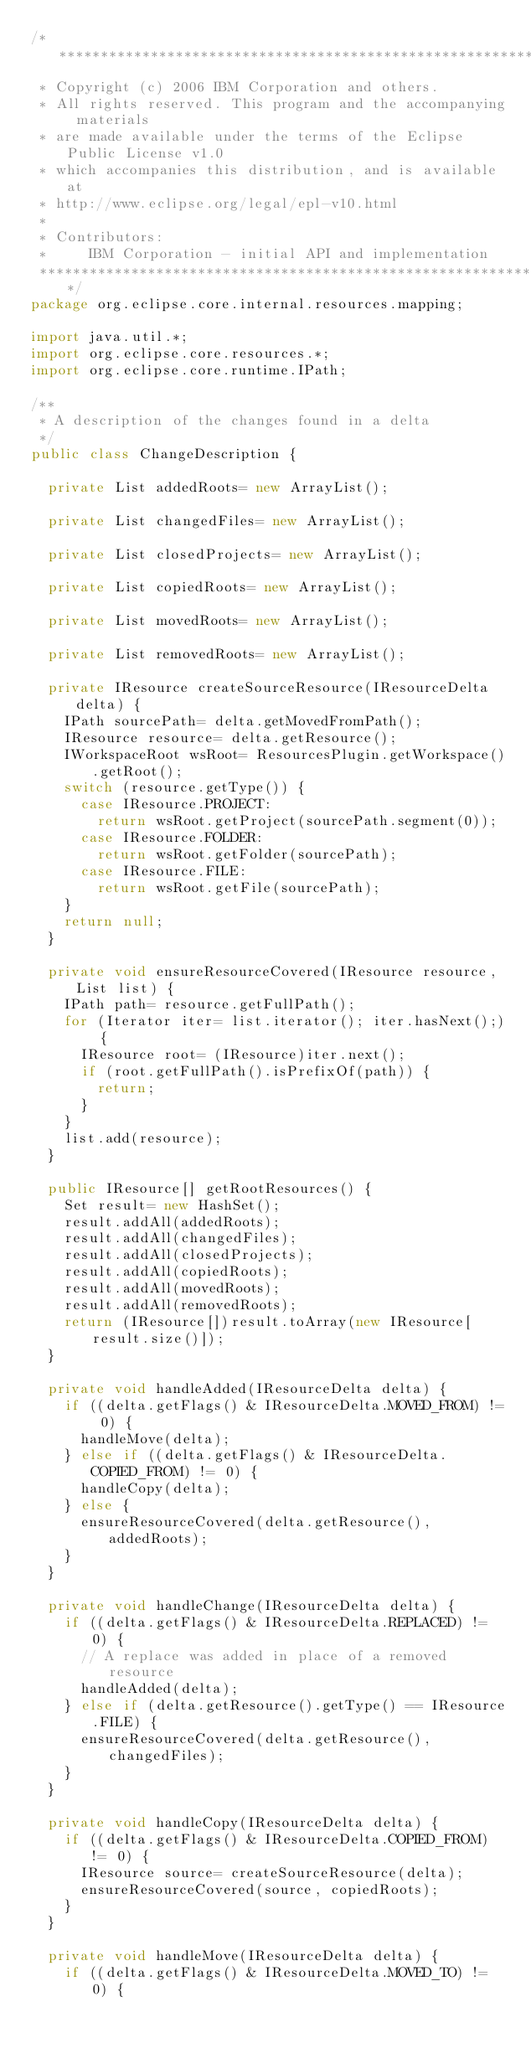<code> <loc_0><loc_0><loc_500><loc_500><_Java_>/*******************************************************************************
 * Copyright (c) 2006 IBM Corporation and others.
 * All rights reserved. This program and the accompanying materials
 * are made available under the terms of the Eclipse Public License v1.0
 * which accompanies this distribution, and is available at
 * http://www.eclipse.org/legal/epl-v10.html
 * 
 * Contributors:
 *     IBM Corporation - initial API and implementation
 *******************************************************************************/
package org.eclipse.core.internal.resources.mapping;

import java.util.*;
import org.eclipse.core.resources.*;
import org.eclipse.core.runtime.IPath;

/**
 * A description of the changes found in a delta
 */
public class ChangeDescription {

	private List addedRoots= new ArrayList();

	private List changedFiles= new ArrayList();

	private List closedProjects= new ArrayList();

	private List copiedRoots= new ArrayList();

	private List movedRoots= new ArrayList();

	private List removedRoots= new ArrayList();

	private IResource createSourceResource(IResourceDelta delta) {
		IPath sourcePath= delta.getMovedFromPath();
		IResource resource= delta.getResource();
		IWorkspaceRoot wsRoot= ResourcesPlugin.getWorkspace().getRoot();
		switch (resource.getType()) {
			case IResource.PROJECT:
				return wsRoot.getProject(sourcePath.segment(0));
			case IResource.FOLDER:
				return wsRoot.getFolder(sourcePath);
			case IResource.FILE:
				return wsRoot.getFile(sourcePath);
		}
		return null;
	}

	private void ensureResourceCovered(IResource resource, List list) {
		IPath path= resource.getFullPath();
		for (Iterator iter= list.iterator(); iter.hasNext();) {
			IResource root= (IResource)iter.next();
			if (root.getFullPath().isPrefixOf(path)) {
				return;
			}
		}
		list.add(resource);
	}

	public IResource[] getRootResources() {
		Set result= new HashSet();
		result.addAll(addedRoots);
		result.addAll(changedFiles);
		result.addAll(closedProjects);
		result.addAll(copiedRoots);
		result.addAll(movedRoots);
		result.addAll(removedRoots);
		return (IResource[])result.toArray(new IResource[result.size()]);
	}

	private void handleAdded(IResourceDelta delta) {
		if ((delta.getFlags() & IResourceDelta.MOVED_FROM) != 0) {
			handleMove(delta);
		} else if ((delta.getFlags() & IResourceDelta.COPIED_FROM) != 0) {
			handleCopy(delta);
		} else {
			ensureResourceCovered(delta.getResource(), addedRoots);
		}
	}

	private void handleChange(IResourceDelta delta) {
		if ((delta.getFlags() & IResourceDelta.REPLACED) != 0) {
			// A replace was added in place of a removed resource
			handleAdded(delta);
		} else if (delta.getResource().getType() == IResource.FILE) {
			ensureResourceCovered(delta.getResource(), changedFiles);
		}
	}

	private void handleCopy(IResourceDelta delta) {
		if ((delta.getFlags() & IResourceDelta.COPIED_FROM) != 0) {
			IResource source= createSourceResource(delta);
			ensureResourceCovered(source, copiedRoots);
		}
	}

	private void handleMove(IResourceDelta delta) {
		if ((delta.getFlags() & IResourceDelta.MOVED_TO) != 0) {</code> 